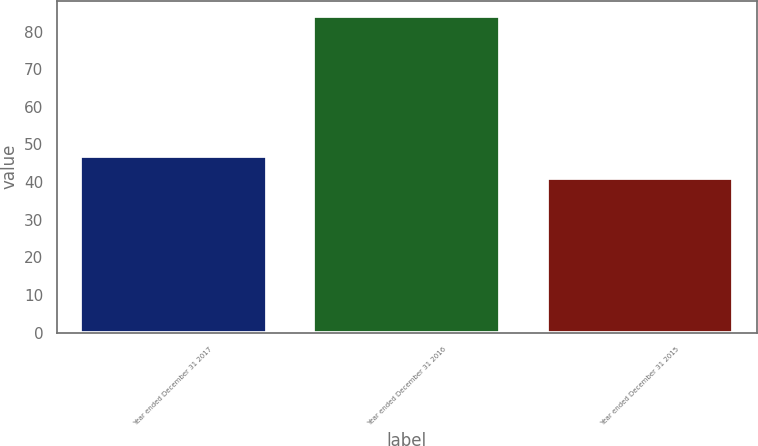Convert chart. <chart><loc_0><loc_0><loc_500><loc_500><bar_chart><fcel>Year ended December 31 2017<fcel>Year ended December 31 2016<fcel>Year ended December 31 2015<nl><fcel>47<fcel>84<fcel>41<nl></chart> 